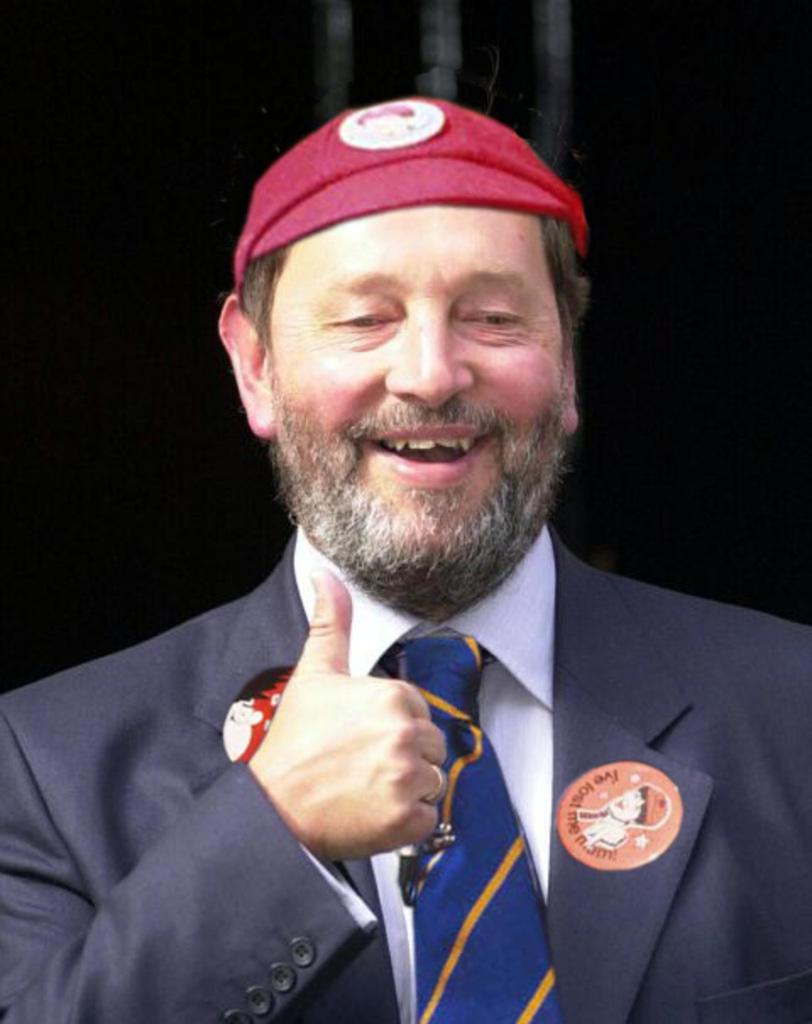What is the main subject of the image? The main subject of the image is a man. What is the man wearing on his head? The man is wearing a red cap. What is the man wearing on his body? The man is wearing a red suit. What can be observed about the background of the image? The background of the image is dark. What type of books can be seen in the image? There are no books or library depicted in the image; it features a man wearing a red cap and red suit with a dark background. 